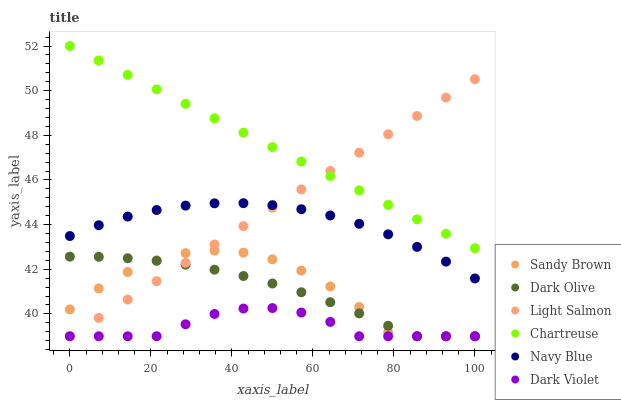Does Dark Violet have the minimum area under the curve?
Answer yes or no. Yes. Does Chartreuse have the maximum area under the curve?
Answer yes or no. Yes. Does Navy Blue have the minimum area under the curve?
Answer yes or no. No. Does Navy Blue have the maximum area under the curve?
Answer yes or no. No. Is Chartreuse the smoothest?
Answer yes or no. Yes. Is Sandy Brown the roughest?
Answer yes or no. Yes. Is Navy Blue the smoothest?
Answer yes or no. No. Is Navy Blue the roughest?
Answer yes or no. No. Does Light Salmon have the lowest value?
Answer yes or no. Yes. Does Navy Blue have the lowest value?
Answer yes or no. No. Does Chartreuse have the highest value?
Answer yes or no. Yes. Does Navy Blue have the highest value?
Answer yes or no. No. Is Navy Blue less than Chartreuse?
Answer yes or no. Yes. Is Chartreuse greater than Navy Blue?
Answer yes or no. Yes. Does Dark Olive intersect Dark Violet?
Answer yes or no. Yes. Is Dark Olive less than Dark Violet?
Answer yes or no. No. Is Dark Olive greater than Dark Violet?
Answer yes or no. No. Does Navy Blue intersect Chartreuse?
Answer yes or no. No. 